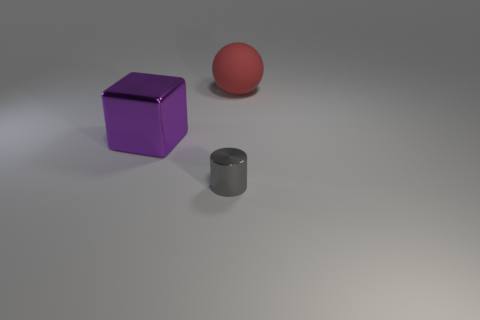Add 2 big rubber spheres. How many objects exist? 5 Subtract all balls. How many objects are left? 2 Subtract all purple metal objects. Subtract all matte objects. How many objects are left? 1 Add 1 matte objects. How many matte objects are left? 2 Add 2 tiny green matte objects. How many tiny green matte objects exist? 2 Subtract 0 yellow spheres. How many objects are left? 3 